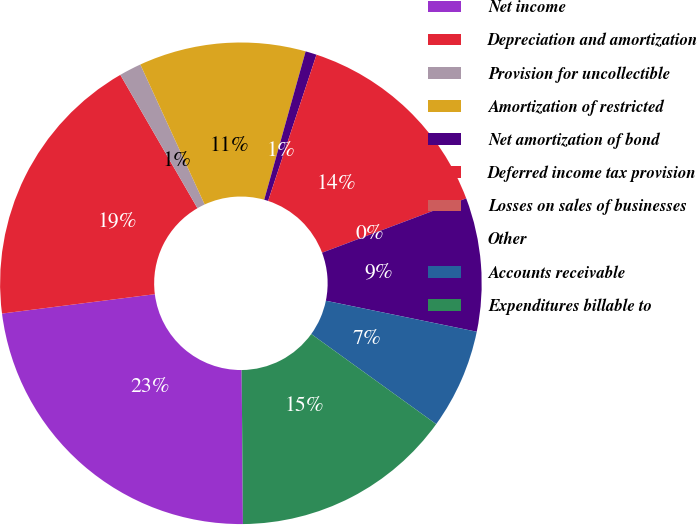Convert chart. <chart><loc_0><loc_0><loc_500><loc_500><pie_chart><fcel>Net income<fcel>Depreciation and amortization<fcel>Provision for uncollectible<fcel>Amortization of restricted<fcel>Net amortization of bond<fcel>Deferred income tax provision<fcel>Losses on sales of businesses<fcel>Other<fcel>Accounts receivable<fcel>Expenditures billable to<nl><fcel>23.13%<fcel>18.66%<fcel>1.49%<fcel>11.19%<fcel>0.75%<fcel>14.18%<fcel>0.0%<fcel>8.96%<fcel>6.72%<fcel>14.92%<nl></chart> 